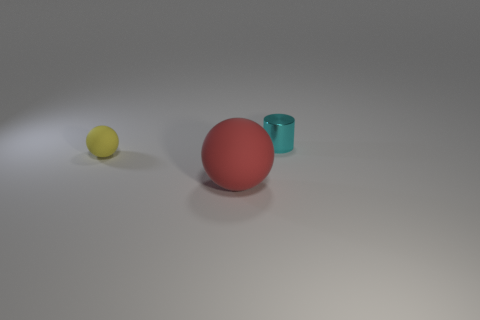Add 2 large purple matte blocks. How many objects exist? 5 Subtract all red balls. How many balls are left? 1 Subtract all cylinders. How many objects are left? 2 Add 2 small rubber objects. How many small rubber objects exist? 3 Subtract 0 red cylinders. How many objects are left? 3 Subtract all purple balls. Subtract all blue cylinders. How many balls are left? 2 Subtract all tiny brown rubber cubes. Subtract all metal cylinders. How many objects are left? 2 Add 2 big red balls. How many big red balls are left? 3 